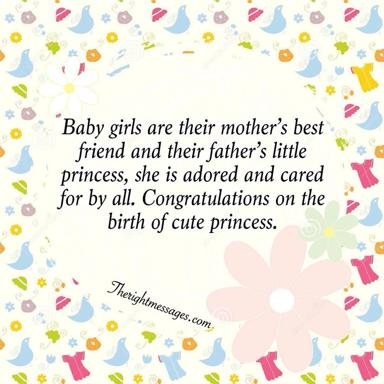What types of flowers are illustrated in the image, and what might their choice signify in the context of a newborn celebration? The flowers depicted are stylized representations of common blooms such as roses and daisies, chosen for their universal appeal and associations with beauty and innocence. In the context of a newborn celebration, these flowers symbolize purity, joy, and new beginnings, often used to convey blessings for a bright and beautiful future for the baby. 